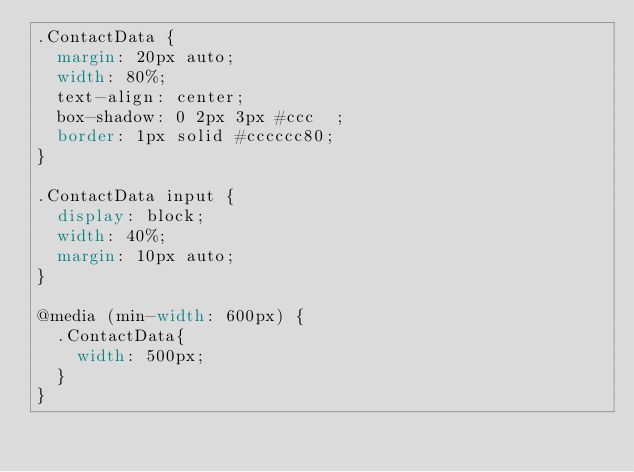Convert code to text. <code><loc_0><loc_0><loc_500><loc_500><_CSS_>.ContactData {
  margin: 20px auto;
  width: 80%;
  text-align: center;
  box-shadow: 0 2px 3px #ccc  ;
  border: 1px solid #cccccc80;
}

.ContactData input {
  display: block;
  width: 40%;
  margin: 10px auto;
}

@media (min-width: 600px) {
  .ContactData{
    width: 500px;
  }
}</code> 